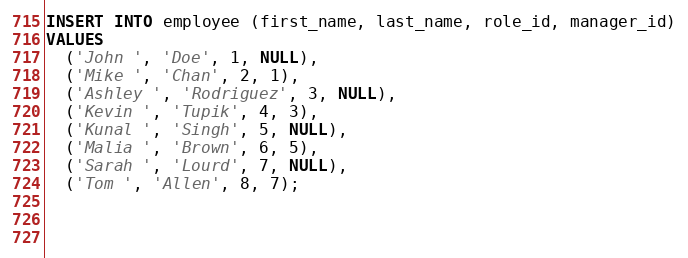Convert code to text. <code><loc_0><loc_0><loc_500><loc_500><_SQL_>INSERT INTO employee (first_name, last_name, role_id, manager_id)
VALUES
  ('John ', 'Doe', 1, NULL),
  ('Mike ', 'Chan', 2, 1),
  ('Ashley ', 'Rodriguez', 3, NULL),
  ('Kevin ', 'Tupik', 4, 3),
  ('Kunal ', 'Singh', 5, NULL),
  ('Malia ', 'Brown', 6, 5),
  ('Sarah ', 'Lourd', 7, NULL),
  ('Tom ', 'Allen', 8, 7);


  </code> 